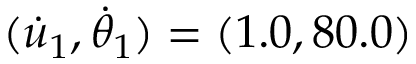<formula> <loc_0><loc_0><loc_500><loc_500>( \dot { u } _ { 1 } , \dot { \theta } _ { 1 } ) = ( 1 . 0 , 8 0 . 0 )</formula> 